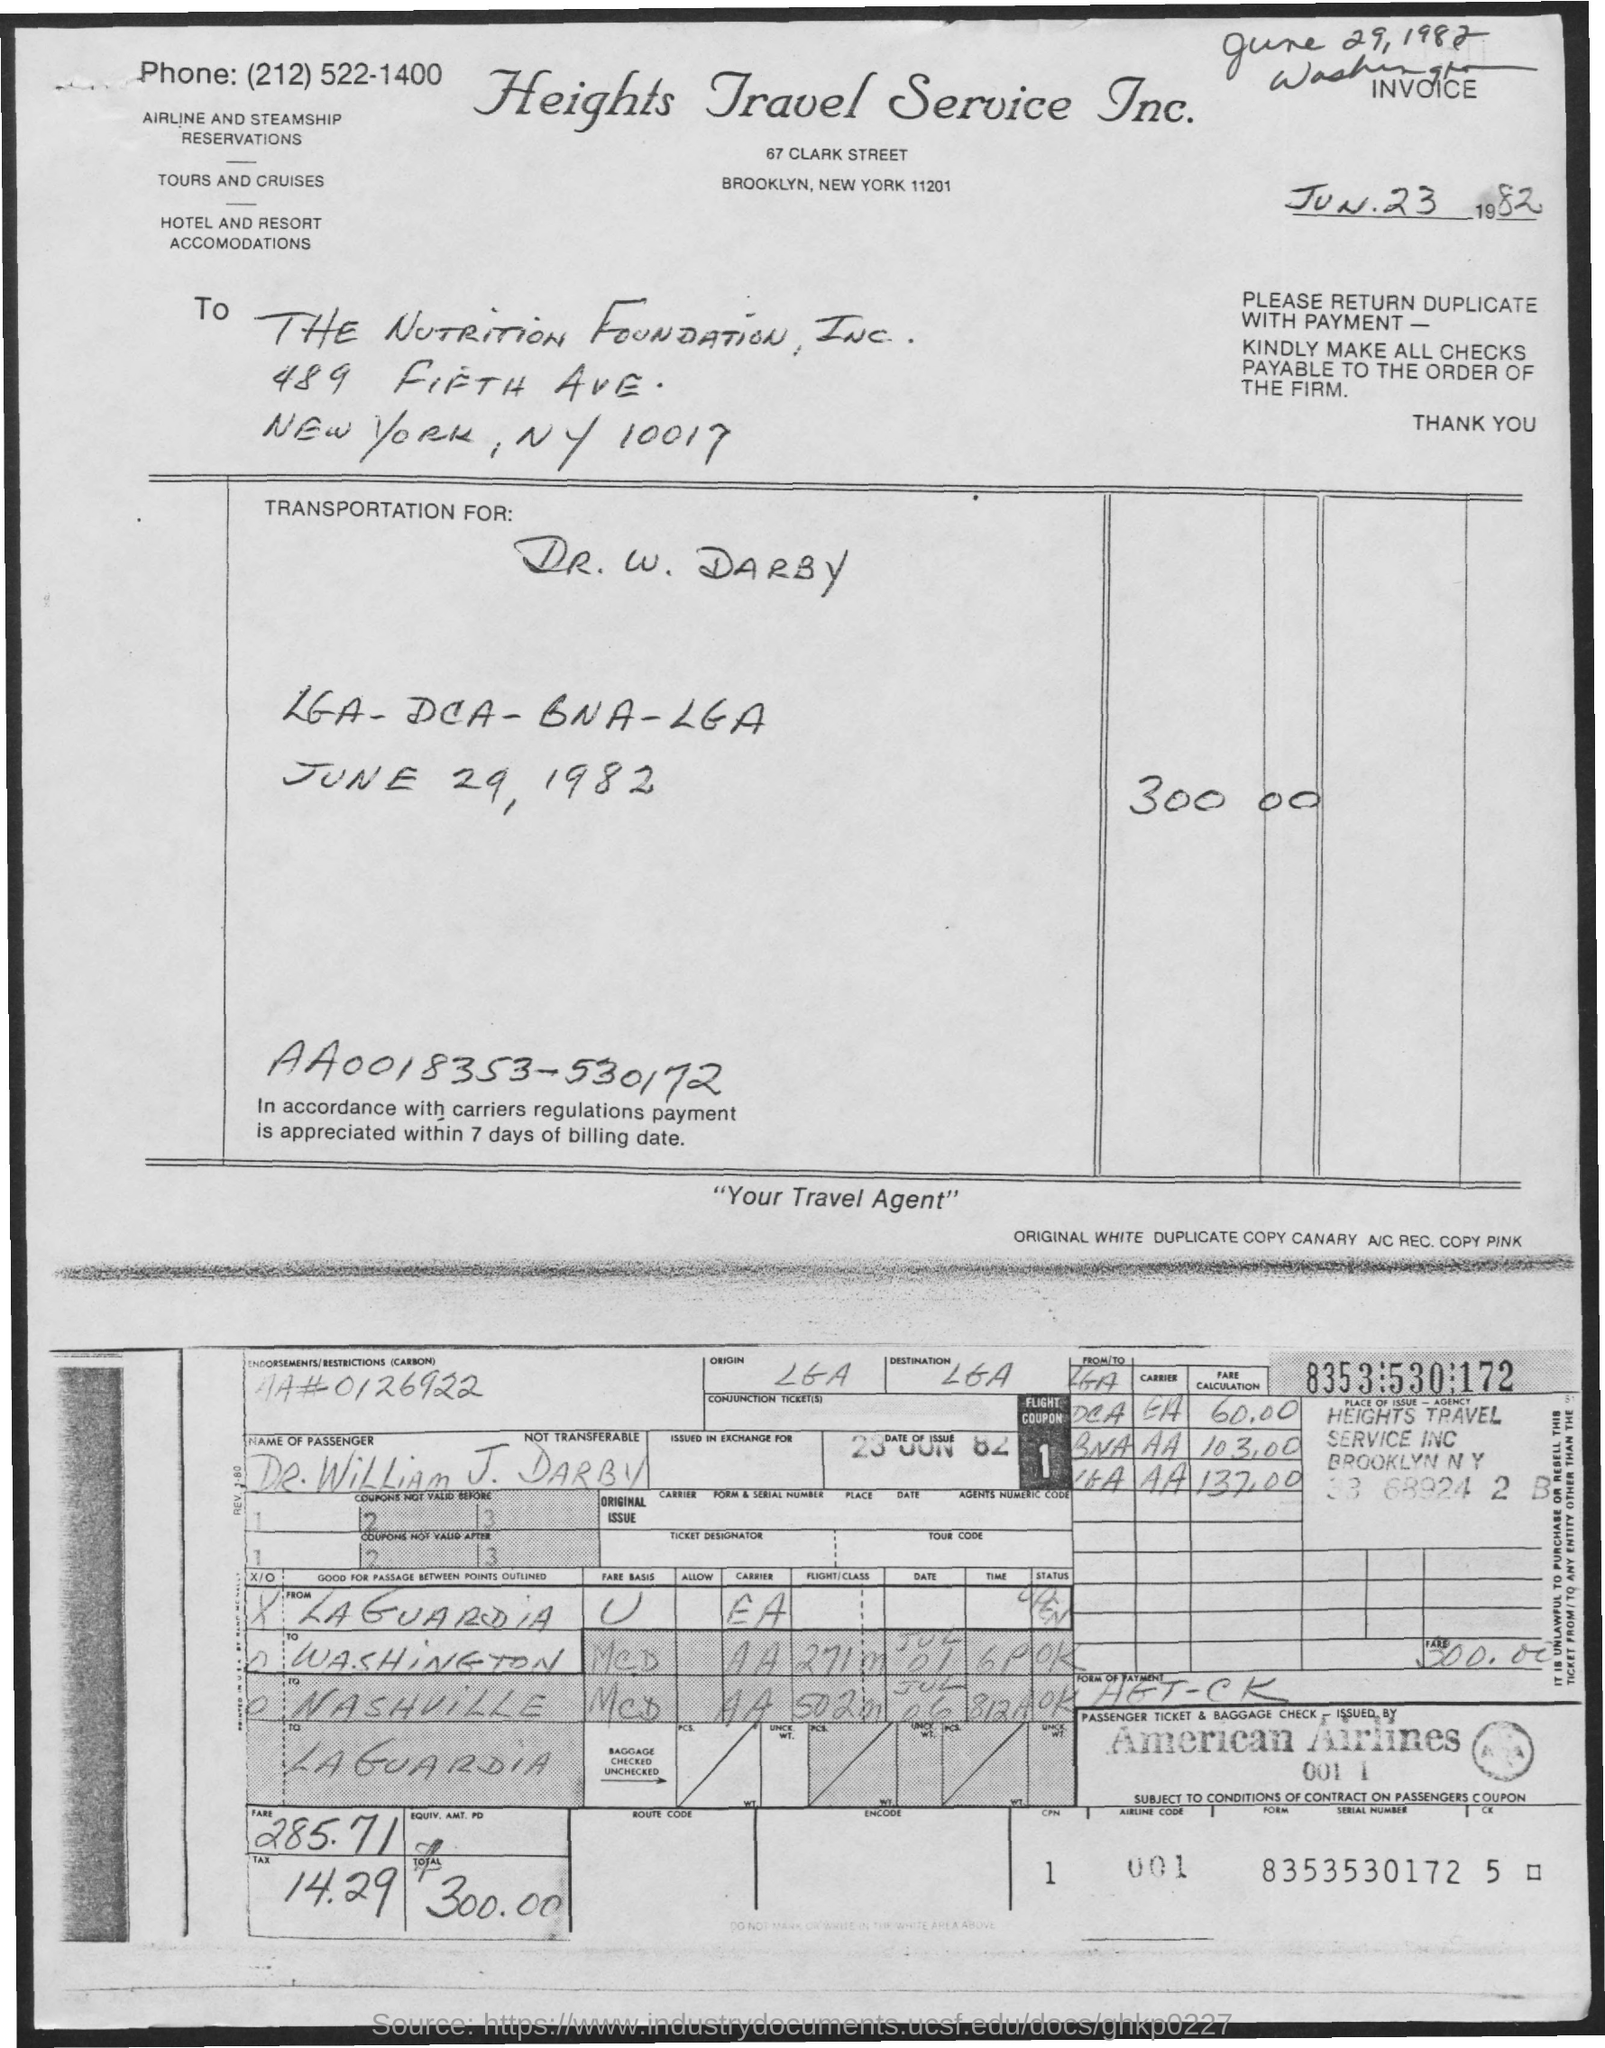Can you tell me the purpose of this document? This is a travel agency invoice from Heights Travel Service Inc., indicating the issuance of an airline ticket and the associated fare and fees. 